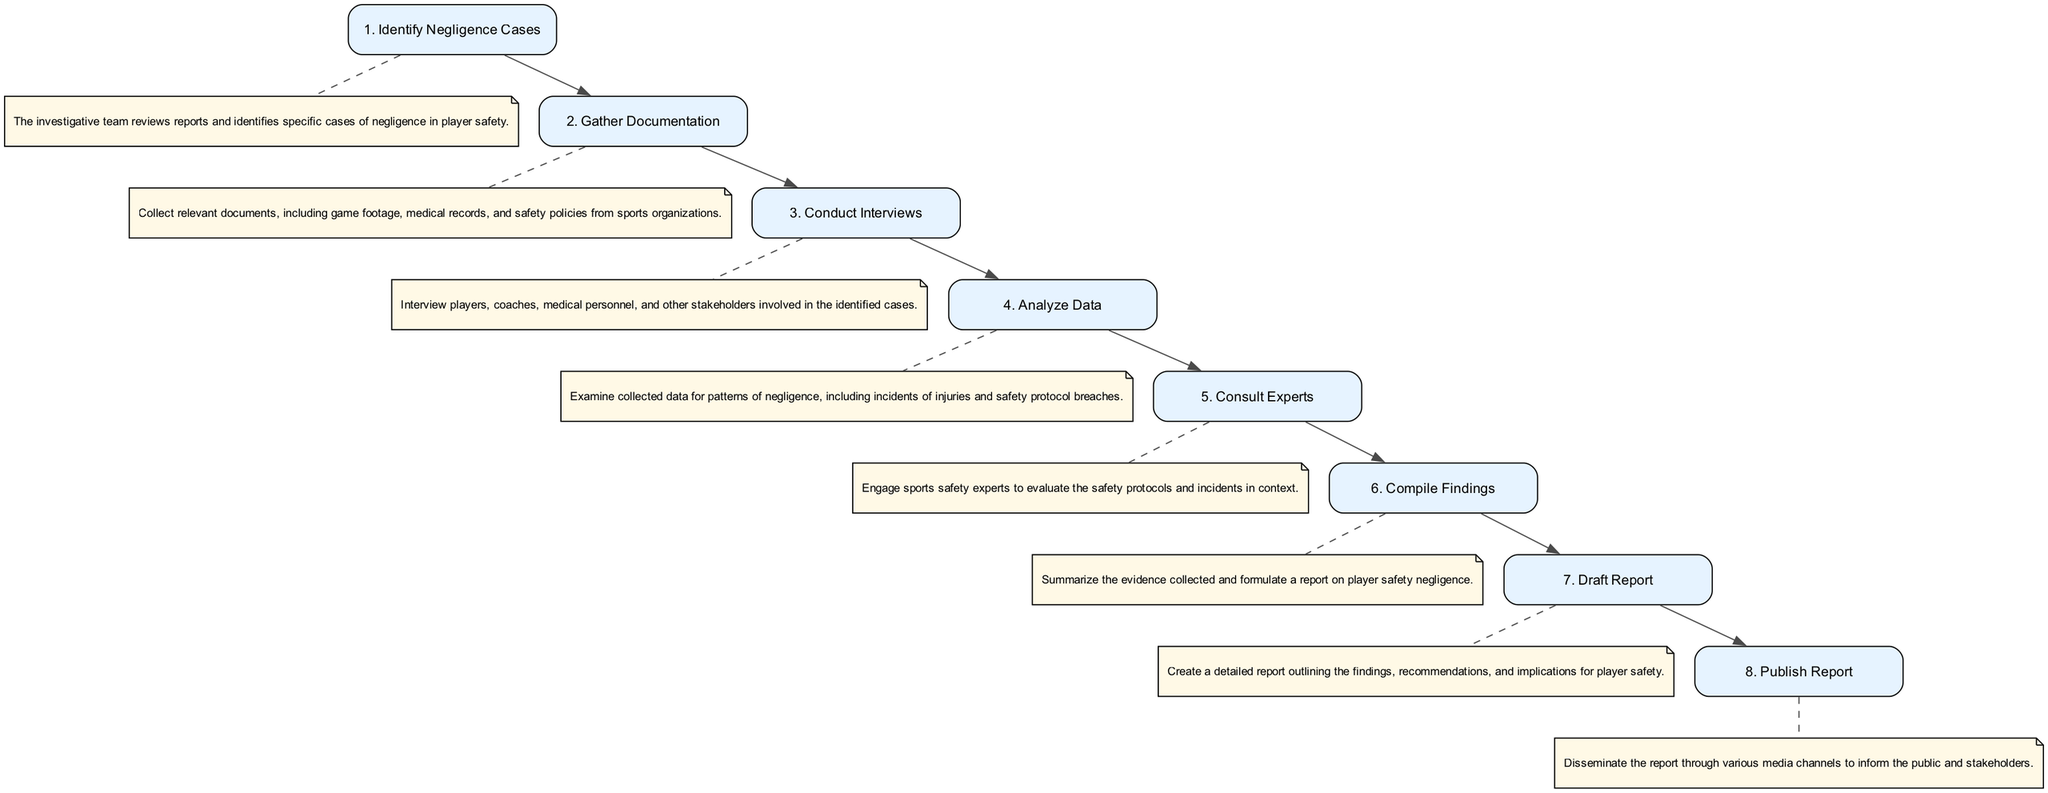What is the first step in the sequence? The first node in the sequence diagram is "Identify Negligence Cases," which is labeled as step 1. This node appears at the top of the flow and represents the initial action taken by the investigative team.
Answer: Identify Negligence Cases How many steps are there in total? By counting the nodes in the sequence diagram, including both steps and descriptions, we find that there are eight distinct steps depicted.
Answer: Eight Which step follows "Conduct Interviews"? The step following "Conduct Interviews" is "Analyze Data," which is connected directly to it in the flow of the diagram.
Answer: Analyze Data What type of information is gathered in the "Gather Documentation" step? This step involves collecting various types of documentation, such as game footage, medical records, and safety policies. This information is crucial for reviewing player safety.
Answer: Documentation Which step has a dashed edge leading to a description? Each step from "Identify Negligence Cases" to "Publish Report" has a dashed edge leading to its corresponding description. The first such edge can be specifically noted in relation to the "Identify Negligence Cases" step.
Answer: Identify Negligence Cases What is the last step in the sequence? The final node in the sequence diagram is "Publish Report," which indicates the conclusion of the investigative steps and the dissemination of findings to the public and stakeholders.
Answer: Publish Report Which steps involve consultation with external parties? The step that explicitly mentions consulting external parties is "Consult Experts," where sports safety experts are engaged to evaluate incidents.
Answer: Consult Experts How does 'Analyze Data' connect to 'Compile Findings'? "Analyze Data" leads directly to "Compile Findings," indicating that analyzing information is a precursor to compiling the overall evidence and forming conclusions.
Answer: Direct connection What is the significance of the note format in the diagram? The note format, evidenced by the dashed edges, indicates descriptions related to each step, providing additional context and elaborating on the actions associated with the corresponding nodes in the diagram.
Answer: Additional context 